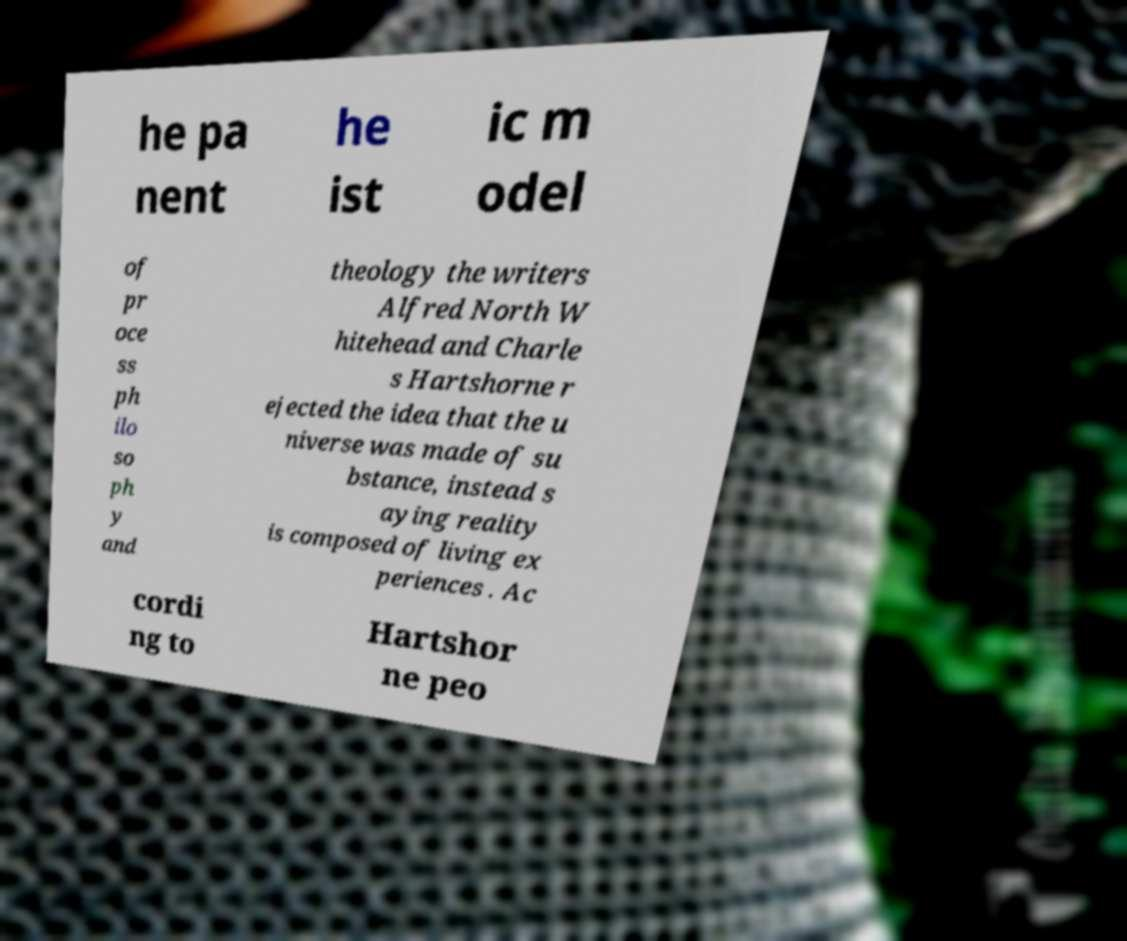What messages or text are displayed in this image? I need them in a readable, typed format. he pa nent he ist ic m odel of pr oce ss ph ilo so ph y and theology the writers Alfred North W hitehead and Charle s Hartshorne r ejected the idea that the u niverse was made of su bstance, instead s aying reality is composed of living ex periences . Ac cordi ng to Hartshor ne peo 